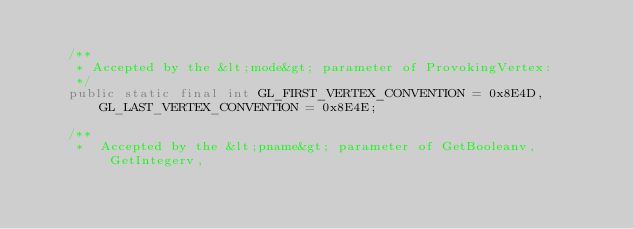Convert code to text. <code><loc_0><loc_0><loc_500><loc_500><_Java_>
	/**
	 * Accepted by the &lt;mode&gt; parameter of ProvokingVertex: 
	 */
	public static final int GL_FIRST_VERTEX_CONVENTION = 0x8E4D,
		GL_LAST_VERTEX_CONVENTION = 0x8E4E;

	/**
	 *  Accepted by the &lt;pname&gt; parameter of GetBooleanv, GetIntegerv,</code> 